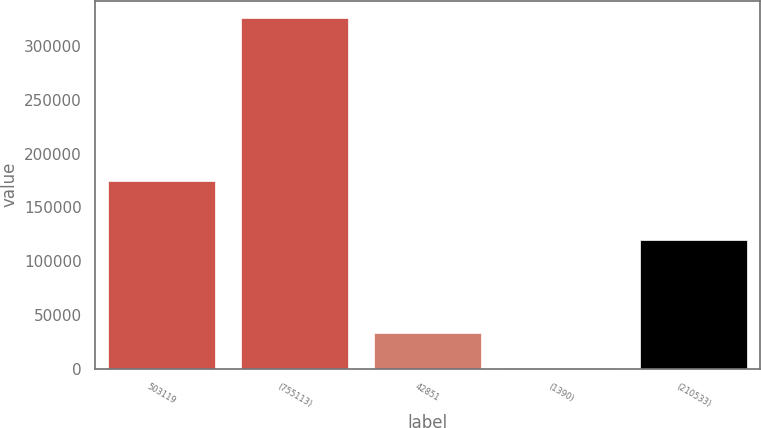Convert chart to OTSL. <chart><loc_0><loc_0><loc_500><loc_500><bar_chart><fcel>503119<fcel>(755113)<fcel>42851<fcel>(1390)<fcel>(210533)<nl><fcel>174295<fcel>325775<fcel>32995.1<fcel>464<fcel>119199<nl></chart> 